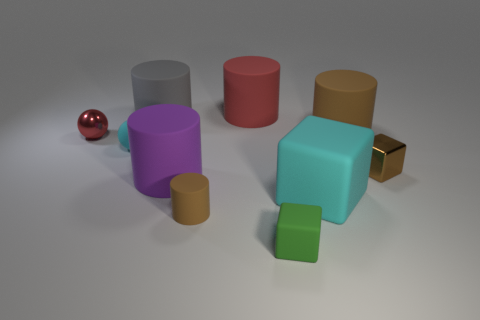Subtract all purple cylinders. How many cylinders are left? 4 Subtract all purple matte cylinders. How many cylinders are left? 4 Subtract all green cylinders. Subtract all purple blocks. How many cylinders are left? 5 Subtract all cubes. How many objects are left? 7 Add 2 rubber spheres. How many rubber spheres are left? 3 Add 6 brown metal cubes. How many brown metal cubes exist? 7 Subtract 0 purple balls. How many objects are left? 10 Subtract all small yellow metallic cylinders. Subtract all big red matte cylinders. How many objects are left? 9 